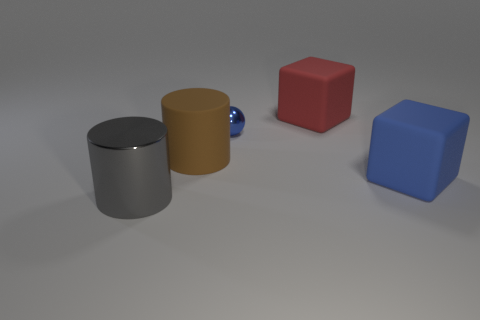Add 4 large metal things. How many objects exist? 9 Subtract all gray cylinders. How many cylinders are left? 1 Subtract all cylinders. How many objects are left? 3 Subtract 2 cylinders. How many cylinders are left? 0 Subtract all large objects. Subtract all large shiny cylinders. How many objects are left? 0 Add 2 cubes. How many cubes are left? 4 Add 1 brown balls. How many brown balls exist? 1 Subtract 0 purple balls. How many objects are left? 5 Subtract all brown cylinders. Subtract all yellow blocks. How many cylinders are left? 1 Subtract all cyan balls. How many yellow cubes are left? 0 